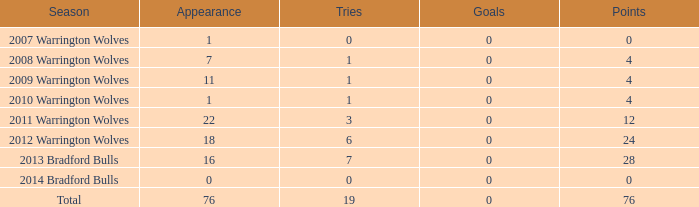What is the minimum occurrence when goals are greater than 0? None. 